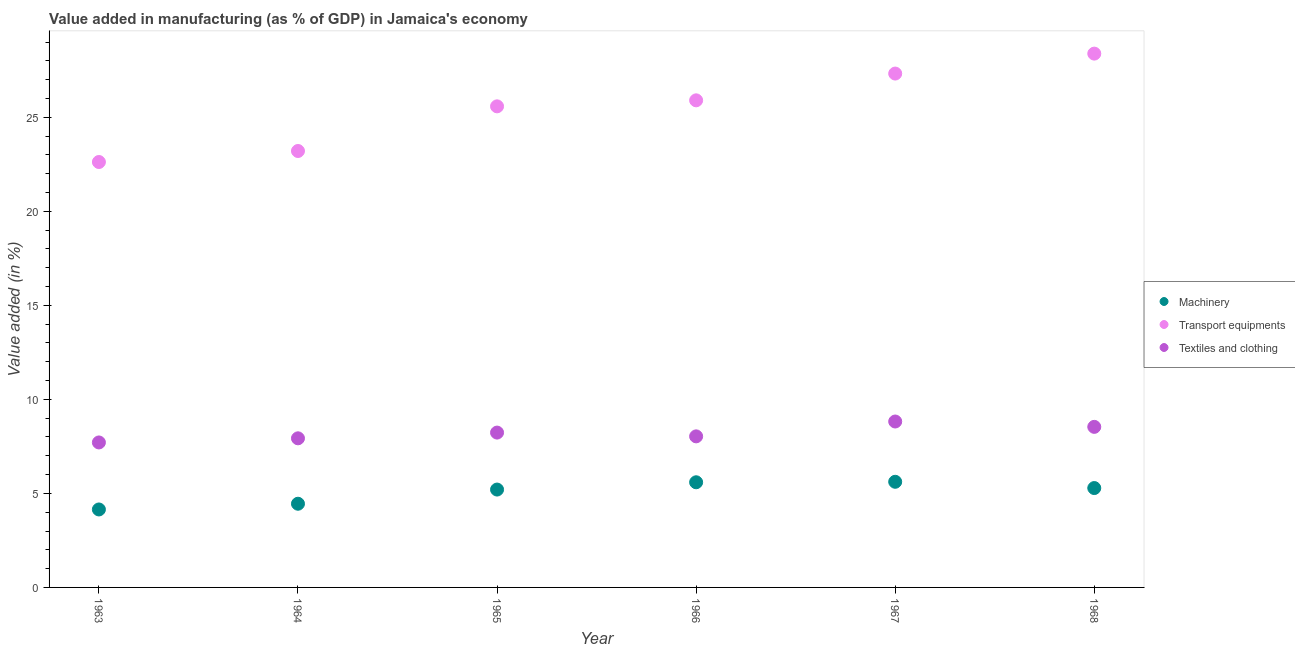Is the number of dotlines equal to the number of legend labels?
Offer a terse response. Yes. What is the value added in manufacturing machinery in 1965?
Your answer should be very brief. 5.2. Across all years, what is the maximum value added in manufacturing transport equipments?
Keep it short and to the point. 28.39. Across all years, what is the minimum value added in manufacturing transport equipments?
Offer a very short reply. 22.62. In which year was the value added in manufacturing transport equipments maximum?
Make the answer very short. 1968. In which year was the value added in manufacturing textile and clothing minimum?
Offer a very short reply. 1963. What is the total value added in manufacturing machinery in the graph?
Offer a very short reply. 30.29. What is the difference between the value added in manufacturing transport equipments in 1965 and that in 1968?
Provide a succinct answer. -2.8. What is the difference between the value added in manufacturing textile and clothing in 1966 and the value added in manufacturing machinery in 1968?
Keep it short and to the point. 2.75. What is the average value added in manufacturing textile and clothing per year?
Ensure brevity in your answer.  8.21. In the year 1966, what is the difference between the value added in manufacturing textile and clothing and value added in manufacturing transport equipments?
Your response must be concise. -17.87. What is the ratio of the value added in manufacturing textile and clothing in 1963 to that in 1967?
Give a very brief answer. 0.87. Is the value added in manufacturing transport equipments in 1964 less than that in 1968?
Keep it short and to the point. Yes. What is the difference between the highest and the second highest value added in manufacturing transport equipments?
Ensure brevity in your answer.  1.06. What is the difference between the highest and the lowest value added in manufacturing textile and clothing?
Offer a very short reply. 1.11. Is the value added in manufacturing transport equipments strictly greater than the value added in manufacturing textile and clothing over the years?
Your response must be concise. Yes. How many years are there in the graph?
Keep it short and to the point. 6. Are the values on the major ticks of Y-axis written in scientific E-notation?
Provide a short and direct response. No. What is the title of the graph?
Give a very brief answer. Value added in manufacturing (as % of GDP) in Jamaica's economy. What is the label or title of the Y-axis?
Offer a terse response. Value added (in %). What is the Value added (in %) in Machinery in 1963?
Offer a very short reply. 4.15. What is the Value added (in %) in Transport equipments in 1963?
Your answer should be very brief. 22.62. What is the Value added (in %) in Textiles and clothing in 1963?
Give a very brief answer. 7.71. What is the Value added (in %) of Machinery in 1964?
Ensure brevity in your answer.  4.45. What is the Value added (in %) of Transport equipments in 1964?
Your answer should be very brief. 23.21. What is the Value added (in %) of Textiles and clothing in 1964?
Your response must be concise. 7.93. What is the Value added (in %) of Machinery in 1965?
Ensure brevity in your answer.  5.2. What is the Value added (in %) of Transport equipments in 1965?
Keep it short and to the point. 25.58. What is the Value added (in %) of Textiles and clothing in 1965?
Offer a very short reply. 8.23. What is the Value added (in %) in Machinery in 1966?
Provide a short and direct response. 5.59. What is the Value added (in %) of Transport equipments in 1966?
Make the answer very short. 25.9. What is the Value added (in %) of Textiles and clothing in 1966?
Provide a short and direct response. 8.03. What is the Value added (in %) of Machinery in 1967?
Your answer should be very brief. 5.62. What is the Value added (in %) of Transport equipments in 1967?
Your answer should be compact. 27.33. What is the Value added (in %) in Textiles and clothing in 1967?
Keep it short and to the point. 8.82. What is the Value added (in %) of Machinery in 1968?
Offer a terse response. 5.28. What is the Value added (in %) in Transport equipments in 1968?
Make the answer very short. 28.39. What is the Value added (in %) of Textiles and clothing in 1968?
Give a very brief answer. 8.54. Across all years, what is the maximum Value added (in %) of Machinery?
Make the answer very short. 5.62. Across all years, what is the maximum Value added (in %) in Transport equipments?
Make the answer very short. 28.39. Across all years, what is the maximum Value added (in %) of Textiles and clothing?
Your response must be concise. 8.82. Across all years, what is the minimum Value added (in %) in Machinery?
Keep it short and to the point. 4.15. Across all years, what is the minimum Value added (in %) of Transport equipments?
Your answer should be compact. 22.62. Across all years, what is the minimum Value added (in %) of Textiles and clothing?
Provide a succinct answer. 7.71. What is the total Value added (in %) of Machinery in the graph?
Provide a short and direct response. 30.29. What is the total Value added (in %) of Transport equipments in the graph?
Your response must be concise. 153.03. What is the total Value added (in %) in Textiles and clothing in the graph?
Your response must be concise. 49.27. What is the difference between the Value added (in %) of Machinery in 1963 and that in 1964?
Provide a succinct answer. -0.3. What is the difference between the Value added (in %) in Transport equipments in 1963 and that in 1964?
Make the answer very short. -0.59. What is the difference between the Value added (in %) of Textiles and clothing in 1963 and that in 1964?
Your answer should be compact. -0.22. What is the difference between the Value added (in %) of Machinery in 1963 and that in 1965?
Offer a very short reply. -1.06. What is the difference between the Value added (in %) of Transport equipments in 1963 and that in 1965?
Your response must be concise. -2.96. What is the difference between the Value added (in %) of Textiles and clothing in 1963 and that in 1965?
Provide a succinct answer. -0.52. What is the difference between the Value added (in %) in Machinery in 1963 and that in 1966?
Offer a terse response. -1.45. What is the difference between the Value added (in %) in Transport equipments in 1963 and that in 1966?
Give a very brief answer. -3.28. What is the difference between the Value added (in %) in Textiles and clothing in 1963 and that in 1966?
Offer a very short reply. -0.32. What is the difference between the Value added (in %) in Machinery in 1963 and that in 1967?
Offer a very short reply. -1.47. What is the difference between the Value added (in %) of Transport equipments in 1963 and that in 1967?
Keep it short and to the point. -4.7. What is the difference between the Value added (in %) of Textiles and clothing in 1963 and that in 1967?
Give a very brief answer. -1.11. What is the difference between the Value added (in %) in Machinery in 1963 and that in 1968?
Offer a very short reply. -1.14. What is the difference between the Value added (in %) of Transport equipments in 1963 and that in 1968?
Offer a terse response. -5.76. What is the difference between the Value added (in %) of Textiles and clothing in 1963 and that in 1968?
Give a very brief answer. -0.83. What is the difference between the Value added (in %) in Machinery in 1964 and that in 1965?
Give a very brief answer. -0.75. What is the difference between the Value added (in %) of Transport equipments in 1964 and that in 1965?
Your response must be concise. -2.37. What is the difference between the Value added (in %) in Textiles and clothing in 1964 and that in 1965?
Ensure brevity in your answer.  -0.3. What is the difference between the Value added (in %) of Machinery in 1964 and that in 1966?
Offer a very short reply. -1.14. What is the difference between the Value added (in %) in Transport equipments in 1964 and that in 1966?
Keep it short and to the point. -2.69. What is the difference between the Value added (in %) in Textiles and clothing in 1964 and that in 1966?
Give a very brief answer. -0.1. What is the difference between the Value added (in %) of Machinery in 1964 and that in 1967?
Make the answer very short. -1.17. What is the difference between the Value added (in %) of Transport equipments in 1964 and that in 1967?
Your answer should be compact. -4.12. What is the difference between the Value added (in %) of Textiles and clothing in 1964 and that in 1967?
Your response must be concise. -0.89. What is the difference between the Value added (in %) of Machinery in 1964 and that in 1968?
Ensure brevity in your answer.  -0.83. What is the difference between the Value added (in %) of Transport equipments in 1964 and that in 1968?
Your response must be concise. -5.18. What is the difference between the Value added (in %) in Textiles and clothing in 1964 and that in 1968?
Give a very brief answer. -0.61. What is the difference between the Value added (in %) in Machinery in 1965 and that in 1966?
Your response must be concise. -0.39. What is the difference between the Value added (in %) of Transport equipments in 1965 and that in 1966?
Give a very brief answer. -0.32. What is the difference between the Value added (in %) in Textiles and clothing in 1965 and that in 1966?
Offer a terse response. 0.2. What is the difference between the Value added (in %) of Machinery in 1965 and that in 1967?
Offer a very short reply. -0.41. What is the difference between the Value added (in %) of Transport equipments in 1965 and that in 1967?
Your answer should be very brief. -1.74. What is the difference between the Value added (in %) of Textiles and clothing in 1965 and that in 1967?
Ensure brevity in your answer.  -0.59. What is the difference between the Value added (in %) in Machinery in 1965 and that in 1968?
Ensure brevity in your answer.  -0.08. What is the difference between the Value added (in %) of Transport equipments in 1965 and that in 1968?
Provide a short and direct response. -2.8. What is the difference between the Value added (in %) in Textiles and clothing in 1965 and that in 1968?
Provide a short and direct response. -0.3. What is the difference between the Value added (in %) in Machinery in 1966 and that in 1967?
Your response must be concise. -0.03. What is the difference between the Value added (in %) in Transport equipments in 1966 and that in 1967?
Offer a very short reply. -1.42. What is the difference between the Value added (in %) in Textiles and clothing in 1966 and that in 1967?
Offer a very short reply. -0.79. What is the difference between the Value added (in %) of Machinery in 1966 and that in 1968?
Ensure brevity in your answer.  0.31. What is the difference between the Value added (in %) of Transport equipments in 1966 and that in 1968?
Your answer should be compact. -2.48. What is the difference between the Value added (in %) of Textiles and clothing in 1966 and that in 1968?
Provide a succinct answer. -0.5. What is the difference between the Value added (in %) of Machinery in 1967 and that in 1968?
Your answer should be compact. 0.33. What is the difference between the Value added (in %) in Transport equipments in 1967 and that in 1968?
Ensure brevity in your answer.  -1.06. What is the difference between the Value added (in %) in Textiles and clothing in 1967 and that in 1968?
Your answer should be compact. 0.29. What is the difference between the Value added (in %) of Machinery in 1963 and the Value added (in %) of Transport equipments in 1964?
Offer a terse response. -19.06. What is the difference between the Value added (in %) in Machinery in 1963 and the Value added (in %) in Textiles and clothing in 1964?
Provide a succinct answer. -3.78. What is the difference between the Value added (in %) of Transport equipments in 1963 and the Value added (in %) of Textiles and clothing in 1964?
Provide a short and direct response. 14.69. What is the difference between the Value added (in %) of Machinery in 1963 and the Value added (in %) of Transport equipments in 1965?
Provide a short and direct response. -21.44. What is the difference between the Value added (in %) of Machinery in 1963 and the Value added (in %) of Textiles and clothing in 1965?
Keep it short and to the point. -4.09. What is the difference between the Value added (in %) in Transport equipments in 1963 and the Value added (in %) in Textiles and clothing in 1965?
Offer a very short reply. 14.39. What is the difference between the Value added (in %) in Machinery in 1963 and the Value added (in %) in Transport equipments in 1966?
Offer a very short reply. -21.76. What is the difference between the Value added (in %) of Machinery in 1963 and the Value added (in %) of Textiles and clothing in 1966?
Provide a short and direct response. -3.89. What is the difference between the Value added (in %) in Transport equipments in 1963 and the Value added (in %) in Textiles and clothing in 1966?
Your answer should be compact. 14.59. What is the difference between the Value added (in %) in Machinery in 1963 and the Value added (in %) in Transport equipments in 1967?
Your response must be concise. -23.18. What is the difference between the Value added (in %) of Machinery in 1963 and the Value added (in %) of Textiles and clothing in 1967?
Offer a terse response. -4.68. What is the difference between the Value added (in %) in Transport equipments in 1963 and the Value added (in %) in Textiles and clothing in 1967?
Offer a very short reply. 13.8. What is the difference between the Value added (in %) in Machinery in 1963 and the Value added (in %) in Transport equipments in 1968?
Offer a very short reply. -24.24. What is the difference between the Value added (in %) in Machinery in 1963 and the Value added (in %) in Textiles and clothing in 1968?
Make the answer very short. -4.39. What is the difference between the Value added (in %) of Transport equipments in 1963 and the Value added (in %) of Textiles and clothing in 1968?
Ensure brevity in your answer.  14.09. What is the difference between the Value added (in %) of Machinery in 1964 and the Value added (in %) of Transport equipments in 1965?
Your answer should be compact. -21.13. What is the difference between the Value added (in %) in Machinery in 1964 and the Value added (in %) in Textiles and clothing in 1965?
Give a very brief answer. -3.78. What is the difference between the Value added (in %) in Transport equipments in 1964 and the Value added (in %) in Textiles and clothing in 1965?
Ensure brevity in your answer.  14.97. What is the difference between the Value added (in %) in Machinery in 1964 and the Value added (in %) in Transport equipments in 1966?
Ensure brevity in your answer.  -21.45. What is the difference between the Value added (in %) in Machinery in 1964 and the Value added (in %) in Textiles and clothing in 1966?
Keep it short and to the point. -3.58. What is the difference between the Value added (in %) of Transport equipments in 1964 and the Value added (in %) of Textiles and clothing in 1966?
Give a very brief answer. 15.18. What is the difference between the Value added (in %) in Machinery in 1964 and the Value added (in %) in Transport equipments in 1967?
Give a very brief answer. -22.88. What is the difference between the Value added (in %) in Machinery in 1964 and the Value added (in %) in Textiles and clothing in 1967?
Provide a succinct answer. -4.37. What is the difference between the Value added (in %) of Transport equipments in 1964 and the Value added (in %) of Textiles and clothing in 1967?
Your response must be concise. 14.39. What is the difference between the Value added (in %) in Machinery in 1964 and the Value added (in %) in Transport equipments in 1968?
Keep it short and to the point. -23.94. What is the difference between the Value added (in %) in Machinery in 1964 and the Value added (in %) in Textiles and clothing in 1968?
Your response must be concise. -4.09. What is the difference between the Value added (in %) of Transport equipments in 1964 and the Value added (in %) of Textiles and clothing in 1968?
Offer a terse response. 14.67. What is the difference between the Value added (in %) in Machinery in 1965 and the Value added (in %) in Transport equipments in 1966?
Your answer should be compact. -20.7. What is the difference between the Value added (in %) of Machinery in 1965 and the Value added (in %) of Textiles and clothing in 1966?
Offer a terse response. -2.83. What is the difference between the Value added (in %) in Transport equipments in 1965 and the Value added (in %) in Textiles and clothing in 1966?
Offer a very short reply. 17.55. What is the difference between the Value added (in %) of Machinery in 1965 and the Value added (in %) of Transport equipments in 1967?
Give a very brief answer. -22.12. What is the difference between the Value added (in %) in Machinery in 1965 and the Value added (in %) in Textiles and clothing in 1967?
Make the answer very short. -3.62. What is the difference between the Value added (in %) in Transport equipments in 1965 and the Value added (in %) in Textiles and clothing in 1967?
Offer a terse response. 16.76. What is the difference between the Value added (in %) in Machinery in 1965 and the Value added (in %) in Transport equipments in 1968?
Offer a terse response. -23.18. What is the difference between the Value added (in %) of Machinery in 1965 and the Value added (in %) of Textiles and clothing in 1968?
Offer a very short reply. -3.33. What is the difference between the Value added (in %) in Transport equipments in 1965 and the Value added (in %) in Textiles and clothing in 1968?
Give a very brief answer. 17.05. What is the difference between the Value added (in %) in Machinery in 1966 and the Value added (in %) in Transport equipments in 1967?
Your response must be concise. -21.73. What is the difference between the Value added (in %) of Machinery in 1966 and the Value added (in %) of Textiles and clothing in 1967?
Your response must be concise. -3.23. What is the difference between the Value added (in %) in Transport equipments in 1966 and the Value added (in %) in Textiles and clothing in 1967?
Give a very brief answer. 17.08. What is the difference between the Value added (in %) in Machinery in 1966 and the Value added (in %) in Transport equipments in 1968?
Give a very brief answer. -22.8. What is the difference between the Value added (in %) of Machinery in 1966 and the Value added (in %) of Textiles and clothing in 1968?
Keep it short and to the point. -2.95. What is the difference between the Value added (in %) of Transport equipments in 1966 and the Value added (in %) of Textiles and clothing in 1968?
Your response must be concise. 17.36. What is the difference between the Value added (in %) of Machinery in 1967 and the Value added (in %) of Transport equipments in 1968?
Offer a very short reply. -22.77. What is the difference between the Value added (in %) in Machinery in 1967 and the Value added (in %) in Textiles and clothing in 1968?
Provide a short and direct response. -2.92. What is the difference between the Value added (in %) in Transport equipments in 1967 and the Value added (in %) in Textiles and clothing in 1968?
Your answer should be very brief. 18.79. What is the average Value added (in %) in Machinery per year?
Offer a terse response. 5.05. What is the average Value added (in %) in Transport equipments per year?
Give a very brief answer. 25.51. What is the average Value added (in %) of Textiles and clothing per year?
Provide a short and direct response. 8.21. In the year 1963, what is the difference between the Value added (in %) of Machinery and Value added (in %) of Transport equipments?
Give a very brief answer. -18.48. In the year 1963, what is the difference between the Value added (in %) of Machinery and Value added (in %) of Textiles and clothing?
Your response must be concise. -3.56. In the year 1963, what is the difference between the Value added (in %) in Transport equipments and Value added (in %) in Textiles and clothing?
Provide a short and direct response. 14.91. In the year 1964, what is the difference between the Value added (in %) of Machinery and Value added (in %) of Transport equipments?
Provide a succinct answer. -18.76. In the year 1964, what is the difference between the Value added (in %) of Machinery and Value added (in %) of Textiles and clothing?
Give a very brief answer. -3.48. In the year 1964, what is the difference between the Value added (in %) of Transport equipments and Value added (in %) of Textiles and clothing?
Your answer should be very brief. 15.28. In the year 1965, what is the difference between the Value added (in %) of Machinery and Value added (in %) of Transport equipments?
Ensure brevity in your answer.  -20.38. In the year 1965, what is the difference between the Value added (in %) in Machinery and Value added (in %) in Textiles and clothing?
Keep it short and to the point. -3.03. In the year 1965, what is the difference between the Value added (in %) of Transport equipments and Value added (in %) of Textiles and clothing?
Keep it short and to the point. 17.35. In the year 1966, what is the difference between the Value added (in %) of Machinery and Value added (in %) of Transport equipments?
Your answer should be compact. -20.31. In the year 1966, what is the difference between the Value added (in %) of Machinery and Value added (in %) of Textiles and clothing?
Your answer should be compact. -2.44. In the year 1966, what is the difference between the Value added (in %) of Transport equipments and Value added (in %) of Textiles and clothing?
Ensure brevity in your answer.  17.87. In the year 1967, what is the difference between the Value added (in %) of Machinery and Value added (in %) of Transport equipments?
Provide a short and direct response. -21.71. In the year 1967, what is the difference between the Value added (in %) in Machinery and Value added (in %) in Textiles and clothing?
Ensure brevity in your answer.  -3.21. In the year 1967, what is the difference between the Value added (in %) of Transport equipments and Value added (in %) of Textiles and clothing?
Offer a very short reply. 18.5. In the year 1968, what is the difference between the Value added (in %) in Machinery and Value added (in %) in Transport equipments?
Keep it short and to the point. -23.1. In the year 1968, what is the difference between the Value added (in %) in Machinery and Value added (in %) in Textiles and clothing?
Your response must be concise. -3.25. In the year 1968, what is the difference between the Value added (in %) in Transport equipments and Value added (in %) in Textiles and clothing?
Ensure brevity in your answer.  19.85. What is the ratio of the Value added (in %) in Machinery in 1963 to that in 1964?
Keep it short and to the point. 0.93. What is the ratio of the Value added (in %) of Transport equipments in 1963 to that in 1964?
Your response must be concise. 0.97. What is the ratio of the Value added (in %) in Textiles and clothing in 1963 to that in 1964?
Make the answer very short. 0.97. What is the ratio of the Value added (in %) in Machinery in 1963 to that in 1965?
Give a very brief answer. 0.8. What is the ratio of the Value added (in %) in Transport equipments in 1963 to that in 1965?
Provide a succinct answer. 0.88. What is the ratio of the Value added (in %) of Textiles and clothing in 1963 to that in 1965?
Offer a very short reply. 0.94. What is the ratio of the Value added (in %) in Machinery in 1963 to that in 1966?
Ensure brevity in your answer.  0.74. What is the ratio of the Value added (in %) of Transport equipments in 1963 to that in 1966?
Your answer should be compact. 0.87. What is the ratio of the Value added (in %) of Textiles and clothing in 1963 to that in 1966?
Ensure brevity in your answer.  0.96. What is the ratio of the Value added (in %) of Machinery in 1963 to that in 1967?
Offer a terse response. 0.74. What is the ratio of the Value added (in %) of Transport equipments in 1963 to that in 1967?
Make the answer very short. 0.83. What is the ratio of the Value added (in %) of Textiles and clothing in 1963 to that in 1967?
Give a very brief answer. 0.87. What is the ratio of the Value added (in %) of Machinery in 1963 to that in 1968?
Keep it short and to the point. 0.78. What is the ratio of the Value added (in %) in Transport equipments in 1963 to that in 1968?
Provide a succinct answer. 0.8. What is the ratio of the Value added (in %) of Textiles and clothing in 1963 to that in 1968?
Provide a short and direct response. 0.9. What is the ratio of the Value added (in %) in Machinery in 1964 to that in 1965?
Keep it short and to the point. 0.86. What is the ratio of the Value added (in %) in Transport equipments in 1964 to that in 1965?
Give a very brief answer. 0.91. What is the ratio of the Value added (in %) of Machinery in 1964 to that in 1966?
Give a very brief answer. 0.8. What is the ratio of the Value added (in %) in Transport equipments in 1964 to that in 1966?
Your answer should be very brief. 0.9. What is the ratio of the Value added (in %) in Textiles and clothing in 1964 to that in 1966?
Offer a terse response. 0.99. What is the ratio of the Value added (in %) of Machinery in 1964 to that in 1967?
Offer a very short reply. 0.79. What is the ratio of the Value added (in %) of Transport equipments in 1964 to that in 1967?
Your answer should be very brief. 0.85. What is the ratio of the Value added (in %) in Textiles and clothing in 1964 to that in 1967?
Provide a succinct answer. 0.9. What is the ratio of the Value added (in %) of Machinery in 1964 to that in 1968?
Provide a short and direct response. 0.84. What is the ratio of the Value added (in %) in Transport equipments in 1964 to that in 1968?
Give a very brief answer. 0.82. What is the ratio of the Value added (in %) in Textiles and clothing in 1964 to that in 1968?
Your response must be concise. 0.93. What is the ratio of the Value added (in %) of Machinery in 1965 to that in 1966?
Ensure brevity in your answer.  0.93. What is the ratio of the Value added (in %) of Textiles and clothing in 1965 to that in 1966?
Make the answer very short. 1.02. What is the ratio of the Value added (in %) in Machinery in 1965 to that in 1967?
Ensure brevity in your answer.  0.93. What is the ratio of the Value added (in %) of Transport equipments in 1965 to that in 1967?
Offer a very short reply. 0.94. What is the ratio of the Value added (in %) in Textiles and clothing in 1965 to that in 1967?
Provide a short and direct response. 0.93. What is the ratio of the Value added (in %) of Transport equipments in 1965 to that in 1968?
Your answer should be compact. 0.9. What is the ratio of the Value added (in %) in Textiles and clothing in 1965 to that in 1968?
Your response must be concise. 0.96. What is the ratio of the Value added (in %) in Machinery in 1966 to that in 1967?
Your response must be concise. 1. What is the ratio of the Value added (in %) in Transport equipments in 1966 to that in 1967?
Provide a short and direct response. 0.95. What is the ratio of the Value added (in %) in Textiles and clothing in 1966 to that in 1967?
Provide a succinct answer. 0.91. What is the ratio of the Value added (in %) in Machinery in 1966 to that in 1968?
Provide a succinct answer. 1.06. What is the ratio of the Value added (in %) of Transport equipments in 1966 to that in 1968?
Your response must be concise. 0.91. What is the ratio of the Value added (in %) in Textiles and clothing in 1966 to that in 1968?
Offer a terse response. 0.94. What is the ratio of the Value added (in %) in Machinery in 1967 to that in 1968?
Give a very brief answer. 1.06. What is the ratio of the Value added (in %) in Transport equipments in 1967 to that in 1968?
Your answer should be very brief. 0.96. What is the ratio of the Value added (in %) of Textiles and clothing in 1967 to that in 1968?
Offer a terse response. 1.03. What is the difference between the highest and the second highest Value added (in %) of Machinery?
Provide a succinct answer. 0.03. What is the difference between the highest and the second highest Value added (in %) in Transport equipments?
Make the answer very short. 1.06. What is the difference between the highest and the second highest Value added (in %) of Textiles and clothing?
Give a very brief answer. 0.29. What is the difference between the highest and the lowest Value added (in %) in Machinery?
Provide a short and direct response. 1.47. What is the difference between the highest and the lowest Value added (in %) of Transport equipments?
Ensure brevity in your answer.  5.76. What is the difference between the highest and the lowest Value added (in %) in Textiles and clothing?
Keep it short and to the point. 1.11. 